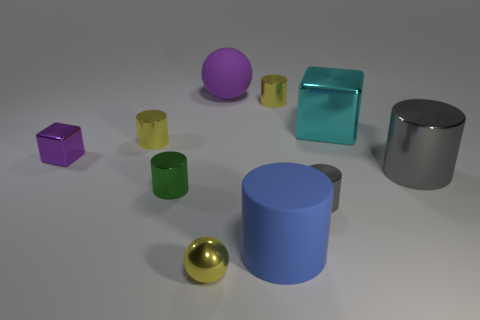Subtract all green metallic cylinders. How many cylinders are left? 5 Subtract all purple balls. How many yellow cylinders are left? 2 Subtract all green cylinders. How many cylinders are left? 5 Subtract 6 cylinders. How many cylinders are left? 0 Subtract all cylinders. How many objects are left? 4 Add 5 small purple objects. How many small purple objects are left? 6 Add 1 large brown rubber spheres. How many large brown rubber spheres exist? 1 Subtract 0 green blocks. How many objects are left? 10 Subtract all cyan cylinders. Subtract all gray balls. How many cylinders are left? 6 Subtract all small yellow shiny objects. Subtract all big shiny cubes. How many objects are left? 6 